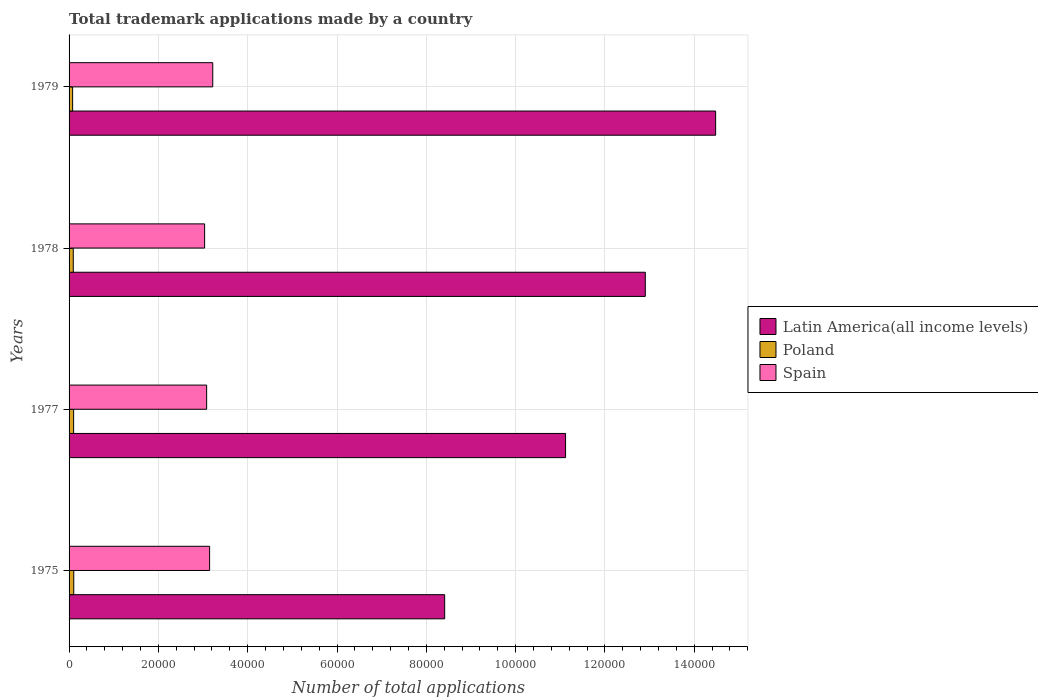How many bars are there on the 1st tick from the bottom?
Your answer should be very brief. 3. What is the label of the 4th group of bars from the top?
Offer a terse response. 1975. In how many cases, is the number of bars for a given year not equal to the number of legend labels?
Provide a short and direct response. 0. What is the number of applications made by in Poland in 1975?
Offer a very short reply. 1052. Across all years, what is the maximum number of applications made by in Spain?
Keep it short and to the point. 3.22e+04. Across all years, what is the minimum number of applications made by in Spain?
Provide a succinct answer. 3.04e+04. In which year was the number of applications made by in Spain maximum?
Provide a short and direct response. 1979. In which year was the number of applications made by in Latin America(all income levels) minimum?
Your response must be concise. 1975. What is the total number of applications made by in Latin America(all income levels) in the graph?
Give a very brief answer. 4.69e+05. What is the difference between the number of applications made by in Poland in 1975 and that in 1979?
Your answer should be compact. 255. What is the difference between the number of applications made by in Poland in 1978 and the number of applications made by in Latin America(all income levels) in 1977?
Offer a terse response. -1.10e+05. What is the average number of applications made by in Spain per year?
Offer a very short reply. 3.12e+04. In the year 1975, what is the difference between the number of applications made by in Poland and number of applications made by in Spain?
Give a very brief answer. -3.04e+04. What is the ratio of the number of applications made by in Poland in 1975 to that in 1979?
Ensure brevity in your answer.  1.32. What is the difference between the highest and the second highest number of applications made by in Latin America(all income levels)?
Provide a short and direct response. 1.57e+04. What is the difference between the highest and the lowest number of applications made by in Latin America(all income levels)?
Offer a very short reply. 6.07e+04. Is the sum of the number of applications made by in Latin America(all income levels) in 1977 and 1978 greater than the maximum number of applications made by in Poland across all years?
Give a very brief answer. Yes. What does the 3rd bar from the top in 1979 represents?
Provide a succinct answer. Latin America(all income levels). What does the 3rd bar from the bottom in 1979 represents?
Your answer should be compact. Spain. How many bars are there?
Offer a terse response. 12. Are the values on the major ticks of X-axis written in scientific E-notation?
Provide a succinct answer. No. Does the graph contain grids?
Keep it short and to the point. Yes. What is the title of the graph?
Provide a short and direct response. Total trademark applications made by a country. Does "Aruba" appear as one of the legend labels in the graph?
Your answer should be compact. No. What is the label or title of the X-axis?
Provide a succinct answer. Number of total applications. What is the Number of total applications in Latin America(all income levels) in 1975?
Give a very brief answer. 8.41e+04. What is the Number of total applications of Poland in 1975?
Your answer should be very brief. 1052. What is the Number of total applications in Spain in 1975?
Provide a succinct answer. 3.15e+04. What is the Number of total applications of Latin America(all income levels) in 1977?
Give a very brief answer. 1.11e+05. What is the Number of total applications of Poland in 1977?
Your answer should be very brief. 1019. What is the Number of total applications in Spain in 1977?
Offer a terse response. 3.08e+04. What is the Number of total applications in Latin America(all income levels) in 1978?
Make the answer very short. 1.29e+05. What is the Number of total applications of Poland in 1978?
Your answer should be compact. 939. What is the Number of total applications of Spain in 1978?
Give a very brief answer. 3.04e+04. What is the Number of total applications in Latin America(all income levels) in 1979?
Make the answer very short. 1.45e+05. What is the Number of total applications in Poland in 1979?
Provide a succinct answer. 797. What is the Number of total applications in Spain in 1979?
Your response must be concise. 3.22e+04. Across all years, what is the maximum Number of total applications of Latin America(all income levels)?
Offer a very short reply. 1.45e+05. Across all years, what is the maximum Number of total applications of Poland?
Offer a terse response. 1052. Across all years, what is the maximum Number of total applications in Spain?
Offer a terse response. 3.22e+04. Across all years, what is the minimum Number of total applications in Latin America(all income levels)?
Make the answer very short. 8.41e+04. Across all years, what is the minimum Number of total applications in Poland?
Provide a short and direct response. 797. Across all years, what is the minimum Number of total applications in Spain?
Offer a terse response. 3.04e+04. What is the total Number of total applications in Latin America(all income levels) in the graph?
Your answer should be compact. 4.69e+05. What is the total Number of total applications in Poland in the graph?
Ensure brevity in your answer.  3807. What is the total Number of total applications of Spain in the graph?
Make the answer very short. 1.25e+05. What is the difference between the Number of total applications in Latin America(all income levels) in 1975 and that in 1977?
Provide a short and direct response. -2.71e+04. What is the difference between the Number of total applications of Spain in 1975 and that in 1977?
Give a very brief answer. 665. What is the difference between the Number of total applications in Latin America(all income levels) in 1975 and that in 1978?
Offer a terse response. -4.49e+04. What is the difference between the Number of total applications in Poland in 1975 and that in 1978?
Ensure brevity in your answer.  113. What is the difference between the Number of total applications in Spain in 1975 and that in 1978?
Give a very brief answer. 1118. What is the difference between the Number of total applications in Latin America(all income levels) in 1975 and that in 1979?
Provide a short and direct response. -6.07e+04. What is the difference between the Number of total applications in Poland in 1975 and that in 1979?
Make the answer very short. 255. What is the difference between the Number of total applications in Spain in 1975 and that in 1979?
Your answer should be compact. -703. What is the difference between the Number of total applications of Latin America(all income levels) in 1977 and that in 1978?
Offer a very short reply. -1.79e+04. What is the difference between the Number of total applications of Poland in 1977 and that in 1978?
Your answer should be very brief. 80. What is the difference between the Number of total applications of Spain in 1977 and that in 1978?
Give a very brief answer. 453. What is the difference between the Number of total applications of Latin America(all income levels) in 1977 and that in 1979?
Provide a succinct answer. -3.36e+04. What is the difference between the Number of total applications in Poland in 1977 and that in 1979?
Your answer should be compact. 222. What is the difference between the Number of total applications in Spain in 1977 and that in 1979?
Ensure brevity in your answer.  -1368. What is the difference between the Number of total applications in Latin America(all income levels) in 1978 and that in 1979?
Offer a terse response. -1.57e+04. What is the difference between the Number of total applications in Poland in 1978 and that in 1979?
Offer a terse response. 142. What is the difference between the Number of total applications of Spain in 1978 and that in 1979?
Keep it short and to the point. -1821. What is the difference between the Number of total applications in Latin America(all income levels) in 1975 and the Number of total applications in Poland in 1977?
Offer a terse response. 8.31e+04. What is the difference between the Number of total applications of Latin America(all income levels) in 1975 and the Number of total applications of Spain in 1977?
Your answer should be compact. 5.33e+04. What is the difference between the Number of total applications in Poland in 1975 and the Number of total applications in Spain in 1977?
Offer a terse response. -2.98e+04. What is the difference between the Number of total applications of Latin America(all income levels) in 1975 and the Number of total applications of Poland in 1978?
Make the answer very short. 8.32e+04. What is the difference between the Number of total applications in Latin America(all income levels) in 1975 and the Number of total applications in Spain in 1978?
Ensure brevity in your answer.  5.38e+04. What is the difference between the Number of total applications in Poland in 1975 and the Number of total applications in Spain in 1978?
Offer a terse response. -2.93e+04. What is the difference between the Number of total applications of Latin America(all income levels) in 1975 and the Number of total applications of Poland in 1979?
Keep it short and to the point. 8.33e+04. What is the difference between the Number of total applications of Latin America(all income levels) in 1975 and the Number of total applications of Spain in 1979?
Make the answer very short. 5.19e+04. What is the difference between the Number of total applications in Poland in 1975 and the Number of total applications in Spain in 1979?
Keep it short and to the point. -3.11e+04. What is the difference between the Number of total applications in Latin America(all income levels) in 1977 and the Number of total applications in Poland in 1978?
Keep it short and to the point. 1.10e+05. What is the difference between the Number of total applications of Latin America(all income levels) in 1977 and the Number of total applications of Spain in 1978?
Provide a short and direct response. 8.08e+04. What is the difference between the Number of total applications of Poland in 1977 and the Number of total applications of Spain in 1978?
Provide a short and direct response. -2.93e+04. What is the difference between the Number of total applications of Latin America(all income levels) in 1977 and the Number of total applications of Poland in 1979?
Your answer should be compact. 1.10e+05. What is the difference between the Number of total applications of Latin America(all income levels) in 1977 and the Number of total applications of Spain in 1979?
Your answer should be very brief. 7.90e+04. What is the difference between the Number of total applications in Poland in 1977 and the Number of total applications in Spain in 1979?
Provide a succinct answer. -3.12e+04. What is the difference between the Number of total applications in Latin America(all income levels) in 1978 and the Number of total applications in Poland in 1979?
Your answer should be compact. 1.28e+05. What is the difference between the Number of total applications in Latin America(all income levels) in 1978 and the Number of total applications in Spain in 1979?
Make the answer very short. 9.69e+04. What is the difference between the Number of total applications in Poland in 1978 and the Number of total applications in Spain in 1979?
Provide a succinct answer. -3.12e+04. What is the average Number of total applications in Latin America(all income levels) per year?
Provide a succinct answer. 1.17e+05. What is the average Number of total applications in Poland per year?
Make the answer very short. 951.75. What is the average Number of total applications in Spain per year?
Your response must be concise. 3.12e+04. In the year 1975, what is the difference between the Number of total applications in Latin America(all income levels) and Number of total applications in Poland?
Your answer should be very brief. 8.31e+04. In the year 1975, what is the difference between the Number of total applications in Latin America(all income levels) and Number of total applications in Spain?
Provide a short and direct response. 5.26e+04. In the year 1975, what is the difference between the Number of total applications in Poland and Number of total applications in Spain?
Offer a very short reply. -3.04e+04. In the year 1977, what is the difference between the Number of total applications in Latin America(all income levels) and Number of total applications in Poland?
Ensure brevity in your answer.  1.10e+05. In the year 1977, what is the difference between the Number of total applications in Latin America(all income levels) and Number of total applications in Spain?
Give a very brief answer. 8.04e+04. In the year 1977, what is the difference between the Number of total applications in Poland and Number of total applications in Spain?
Offer a very short reply. -2.98e+04. In the year 1978, what is the difference between the Number of total applications in Latin America(all income levels) and Number of total applications in Poland?
Keep it short and to the point. 1.28e+05. In the year 1978, what is the difference between the Number of total applications of Latin America(all income levels) and Number of total applications of Spain?
Keep it short and to the point. 9.87e+04. In the year 1978, what is the difference between the Number of total applications in Poland and Number of total applications in Spain?
Keep it short and to the point. -2.94e+04. In the year 1979, what is the difference between the Number of total applications in Latin America(all income levels) and Number of total applications in Poland?
Ensure brevity in your answer.  1.44e+05. In the year 1979, what is the difference between the Number of total applications in Latin America(all income levels) and Number of total applications in Spain?
Give a very brief answer. 1.13e+05. In the year 1979, what is the difference between the Number of total applications of Poland and Number of total applications of Spain?
Make the answer very short. -3.14e+04. What is the ratio of the Number of total applications of Latin America(all income levels) in 1975 to that in 1977?
Your answer should be compact. 0.76. What is the ratio of the Number of total applications of Poland in 1975 to that in 1977?
Provide a succinct answer. 1.03. What is the ratio of the Number of total applications in Spain in 1975 to that in 1977?
Offer a very short reply. 1.02. What is the ratio of the Number of total applications in Latin America(all income levels) in 1975 to that in 1978?
Ensure brevity in your answer.  0.65. What is the ratio of the Number of total applications in Poland in 1975 to that in 1978?
Provide a short and direct response. 1.12. What is the ratio of the Number of total applications in Spain in 1975 to that in 1978?
Offer a very short reply. 1.04. What is the ratio of the Number of total applications of Latin America(all income levels) in 1975 to that in 1979?
Your answer should be compact. 0.58. What is the ratio of the Number of total applications in Poland in 1975 to that in 1979?
Keep it short and to the point. 1.32. What is the ratio of the Number of total applications of Spain in 1975 to that in 1979?
Keep it short and to the point. 0.98. What is the ratio of the Number of total applications in Latin America(all income levels) in 1977 to that in 1978?
Ensure brevity in your answer.  0.86. What is the ratio of the Number of total applications of Poland in 1977 to that in 1978?
Your answer should be very brief. 1.09. What is the ratio of the Number of total applications of Spain in 1977 to that in 1978?
Offer a terse response. 1.01. What is the ratio of the Number of total applications of Latin America(all income levels) in 1977 to that in 1979?
Give a very brief answer. 0.77. What is the ratio of the Number of total applications in Poland in 1977 to that in 1979?
Your answer should be compact. 1.28. What is the ratio of the Number of total applications in Spain in 1977 to that in 1979?
Keep it short and to the point. 0.96. What is the ratio of the Number of total applications in Latin America(all income levels) in 1978 to that in 1979?
Your answer should be very brief. 0.89. What is the ratio of the Number of total applications of Poland in 1978 to that in 1979?
Offer a terse response. 1.18. What is the ratio of the Number of total applications of Spain in 1978 to that in 1979?
Make the answer very short. 0.94. What is the difference between the highest and the second highest Number of total applications of Latin America(all income levels)?
Your answer should be very brief. 1.57e+04. What is the difference between the highest and the second highest Number of total applications of Poland?
Keep it short and to the point. 33. What is the difference between the highest and the second highest Number of total applications in Spain?
Provide a short and direct response. 703. What is the difference between the highest and the lowest Number of total applications in Latin America(all income levels)?
Your answer should be compact. 6.07e+04. What is the difference between the highest and the lowest Number of total applications of Poland?
Your answer should be very brief. 255. What is the difference between the highest and the lowest Number of total applications of Spain?
Provide a succinct answer. 1821. 